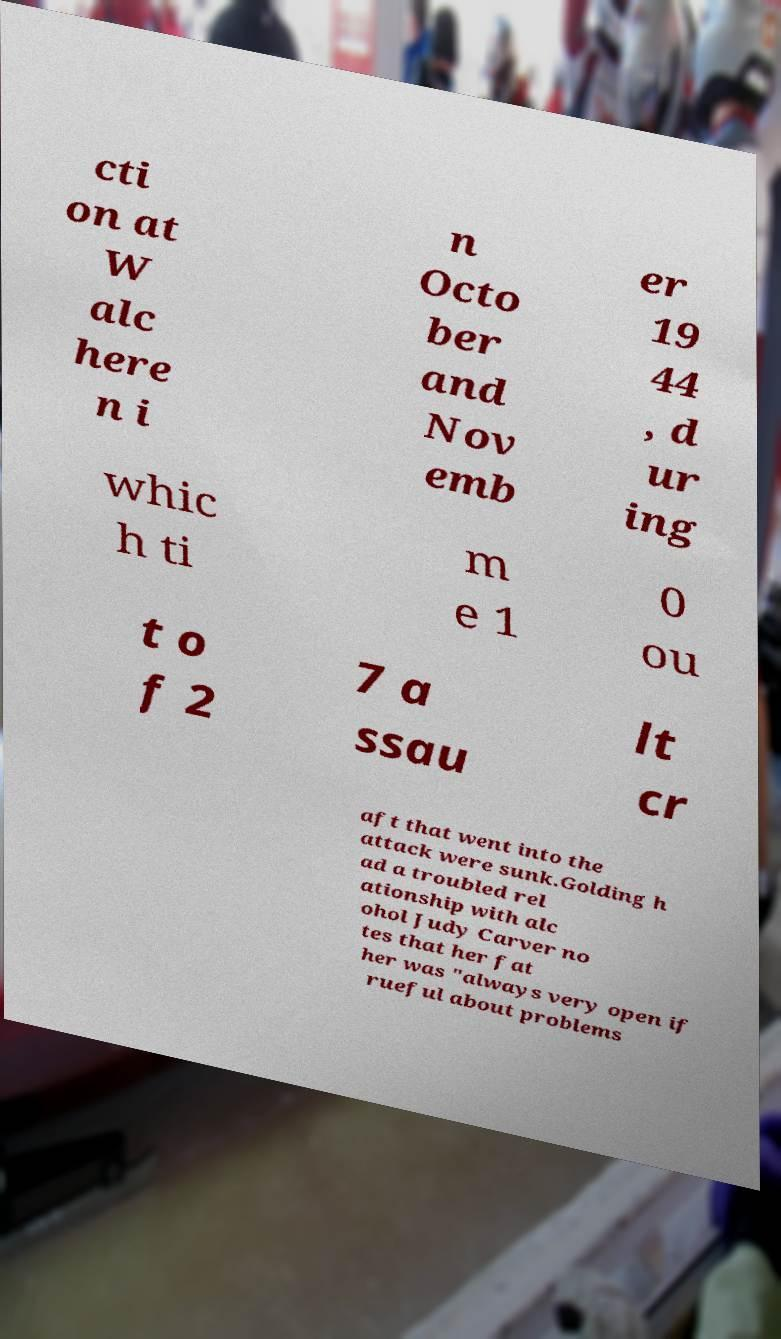There's text embedded in this image that I need extracted. Can you transcribe it verbatim? cti on at W alc here n i n Octo ber and Nov emb er 19 44 , d ur ing whic h ti m e 1 0 ou t o f 2 7 a ssau lt cr aft that went into the attack were sunk.Golding h ad a troubled rel ationship with alc ohol Judy Carver no tes that her fat her was "always very open if rueful about problems 